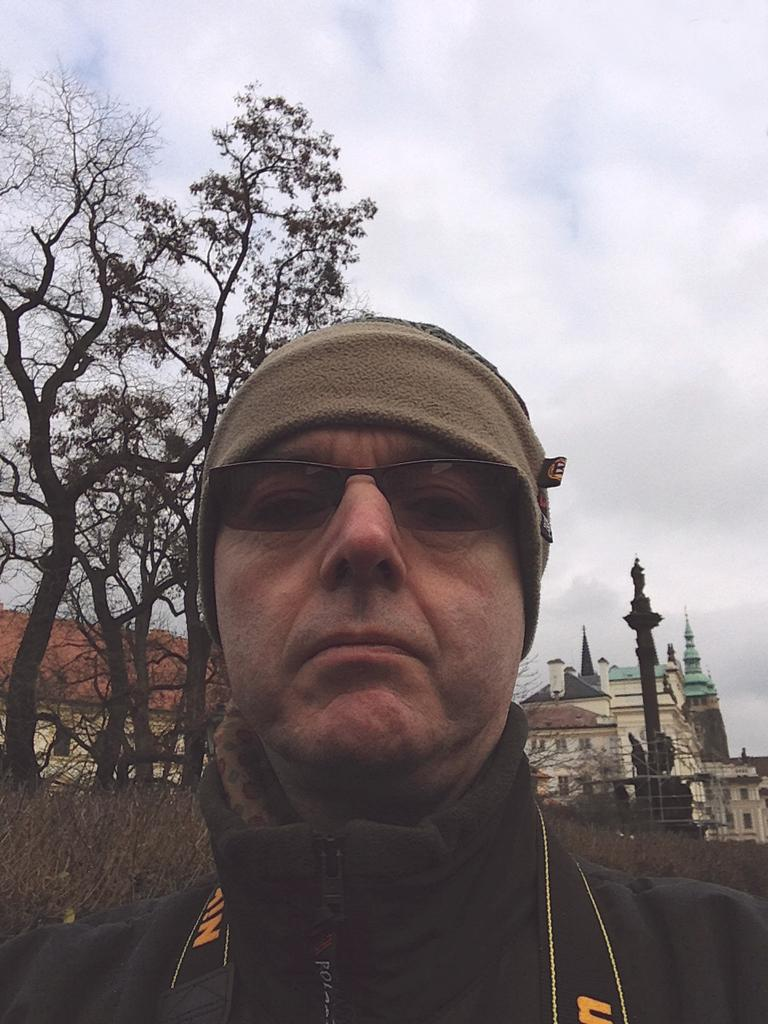What is the main subject of the image? There is a person standing in the center of the image. What can be seen in the background of the image? Sky, clouds, trees, buildings, and grass are visible in the background of the image. Can you describe the natural elements in the background? Trees and grass are the natural elements present in the background. What type of pollution can be seen in the image? There is no pollution visible in the image. Can you tell me how many robins are perched on the trees in the image? There are no robins present in the image; only trees are visible in the background. 